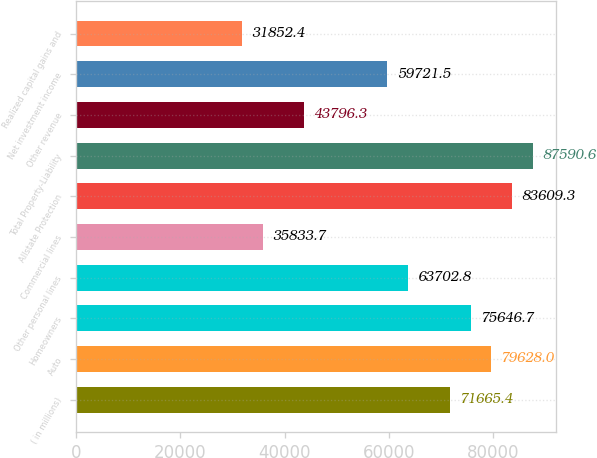<chart> <loc_0><loc_0><loc_500><loc_500><bar_chart><fcel>( in millions)<fcel>Auto<fcel>Homeowners<fcel>Other personal lines<fcel>Commercial lines<fcel>Allstate Protection<fcel>Total Property-Liability<fcel>Other revenue<fcel>Net investment income<fcel>Realized capital gains and<nl><fcel>71665.4<fcel>79628<fcel>75646.7<fcel>63702.8<fcel>35833.7<fcel>83609.3<fcel>87590.6<fcel>43796.3<fcel>59721.5<fcel>31852.4<nl></chart> 